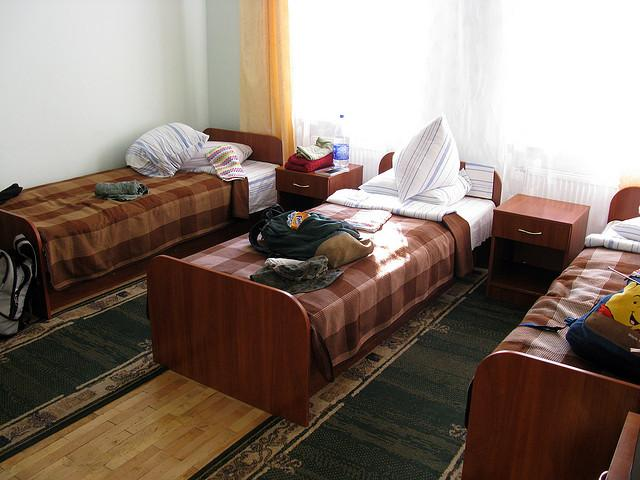What color is the face of the cartoon character on the backpack on the far right bed?

Choices:
A) orange
B) blue
C) brown
D) yellow yellow 